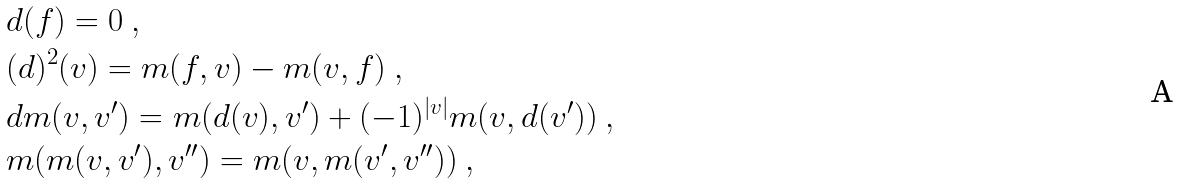Convert formula to latex. <formula><loc_0><loc_0><loc_500><loc_500>& d ( f ) = 0 \ , \\ & ( d ) ^ { 2 } ( v ) = m ( f , v ) - m ( v , f ) \ , \\ & d m ( v , v ^ { \prime } ) = m ( d ( v ) , v ^ { \prime } ) + ( - 1 ) ^ { | v | } m ( v , d ( v ^ { \prime } ) ) \ , \\ & m ( m ( v , v ^ { \prime } ) , v ^ { \prime \prime } ) = m ( v , m ( v ^ { \prime } , v ^ { \prime \prime } ) ) \ ,</formula> 